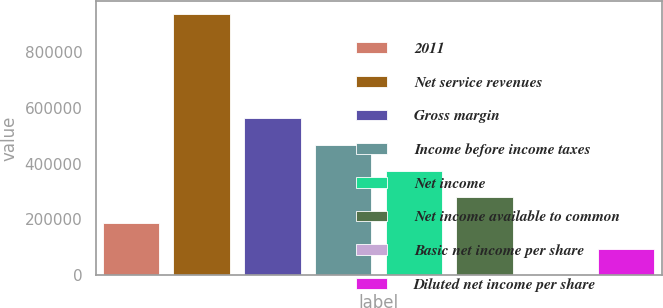<chart> <loc_0><loc_0><loc_500><loc_500><bar_chart><fcel>2011<fcel>Net service revenues<fcel>Gross margin<fcel>Income before income taxes<fcel>Net income<fcel>Net income available to common<fcel>Basic net income per share<fcel>Diluted net income per share<nl><fcel>187593<fcel>937966<fcel>562780<fcel>468983<fcel>375187<fcel>281390<fcel>0.25<fcel>93796.8<nl></chart> 